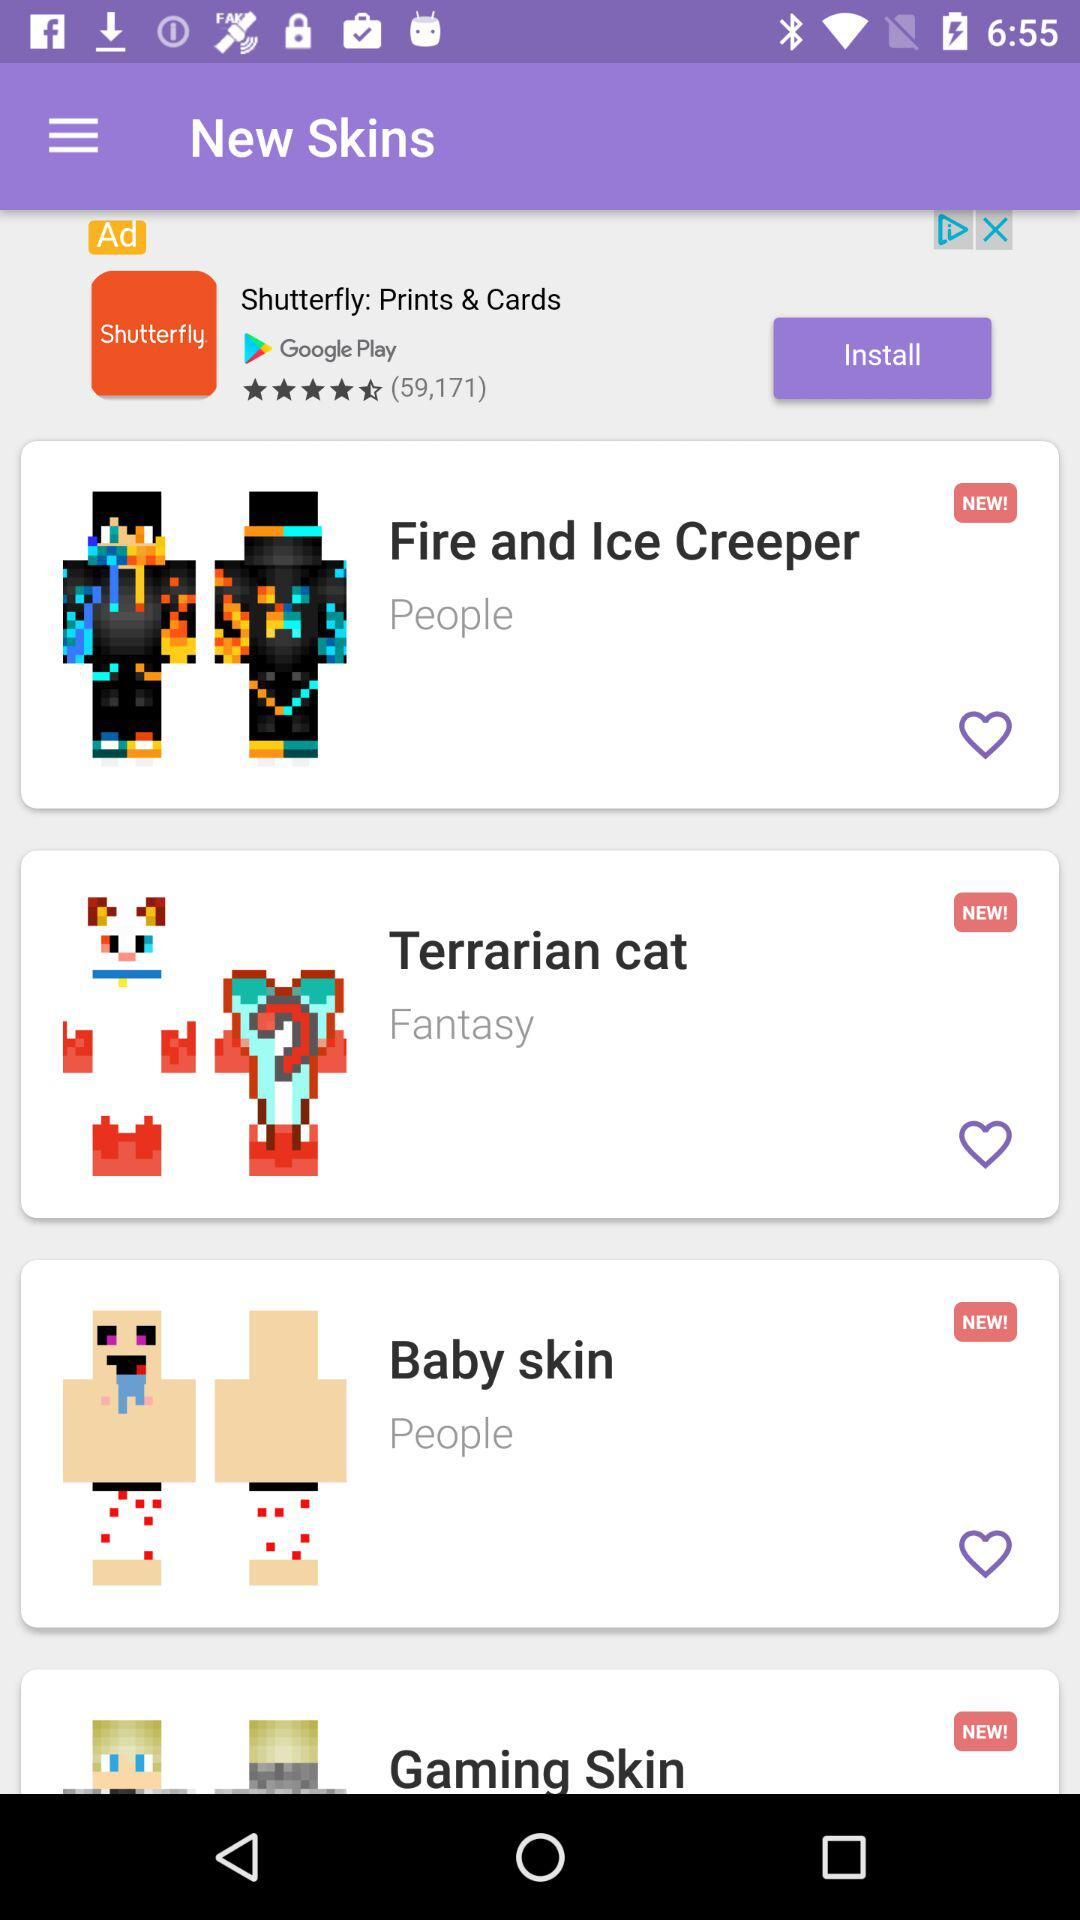Fantasy is the new skin type of what? Fantasy is the new skin type of the Terrarian cat. 